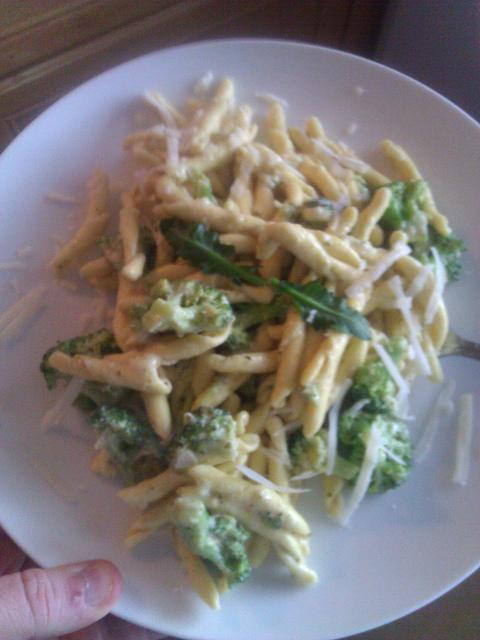Why is the leaf on top? garnish 